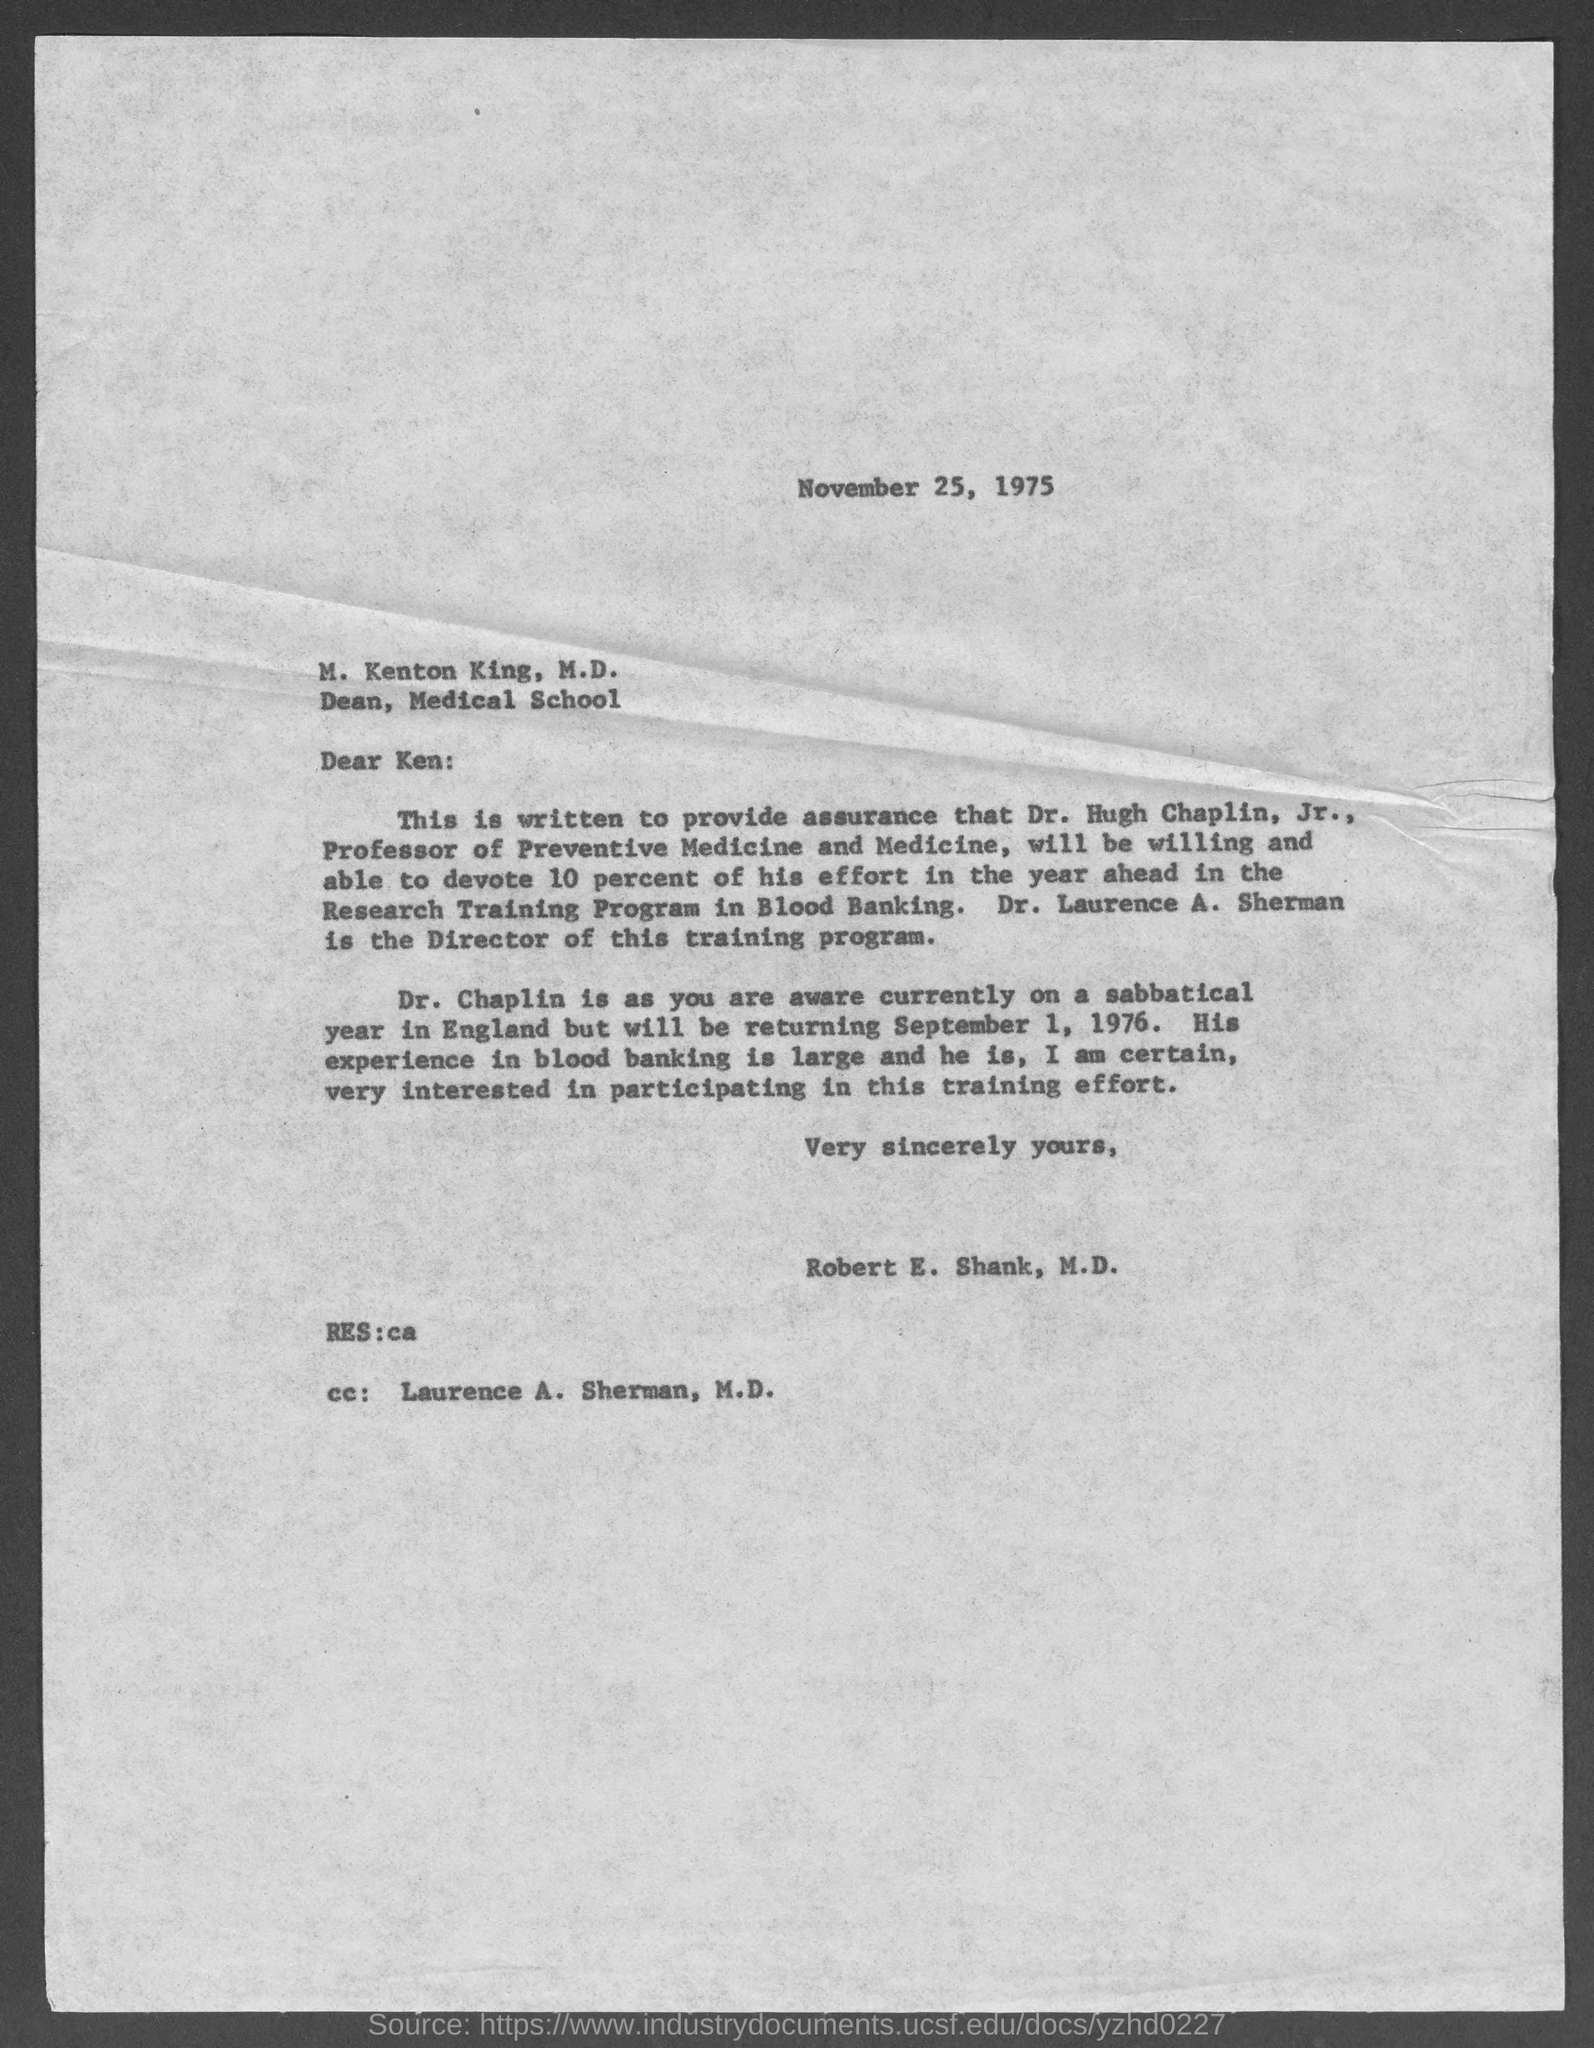What is the date written on the letter?
Give a very brief answer. November 25, 1975. Who is the Director of this training program?
Your answer should be very brief. Dr. Laurence A. Sherman. 